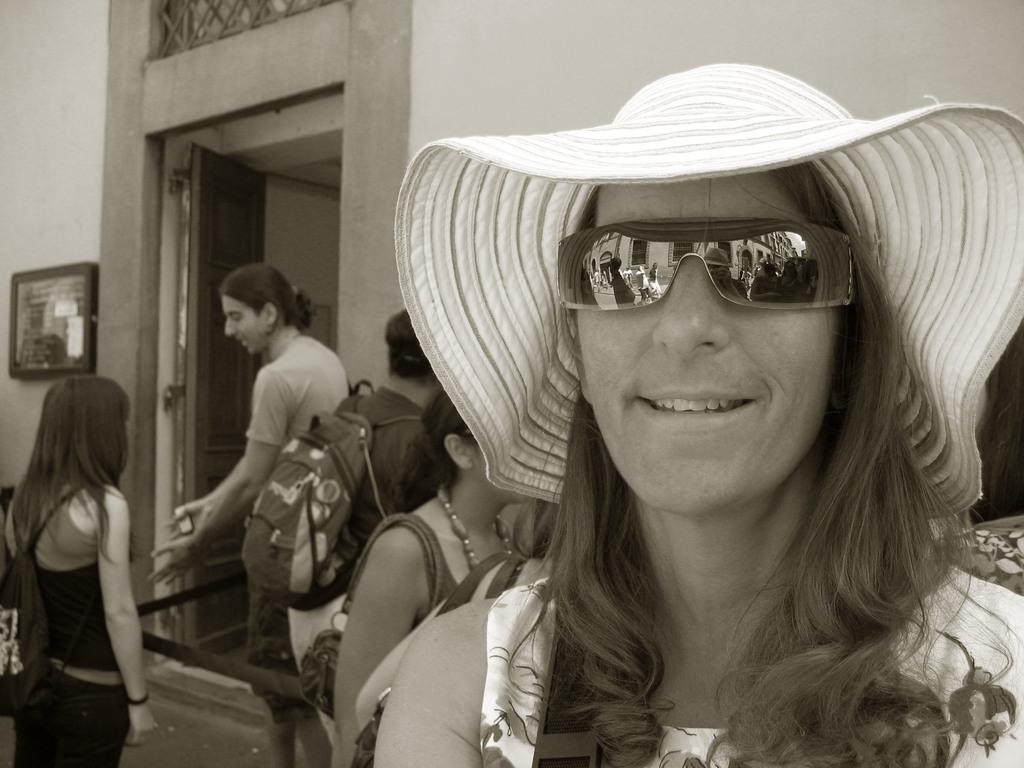What is happening in the image? There are people standing in the image. Can you describe the attire of the person on the right side? The person on the right side is wearing a cap and goggles. What can be seen in the background of the image? There is a wall in the background of the image. What type of toys does the owner of the cap have in the image? There is no reference to an owner or toys in the image, so it is not possible to answer that question. 